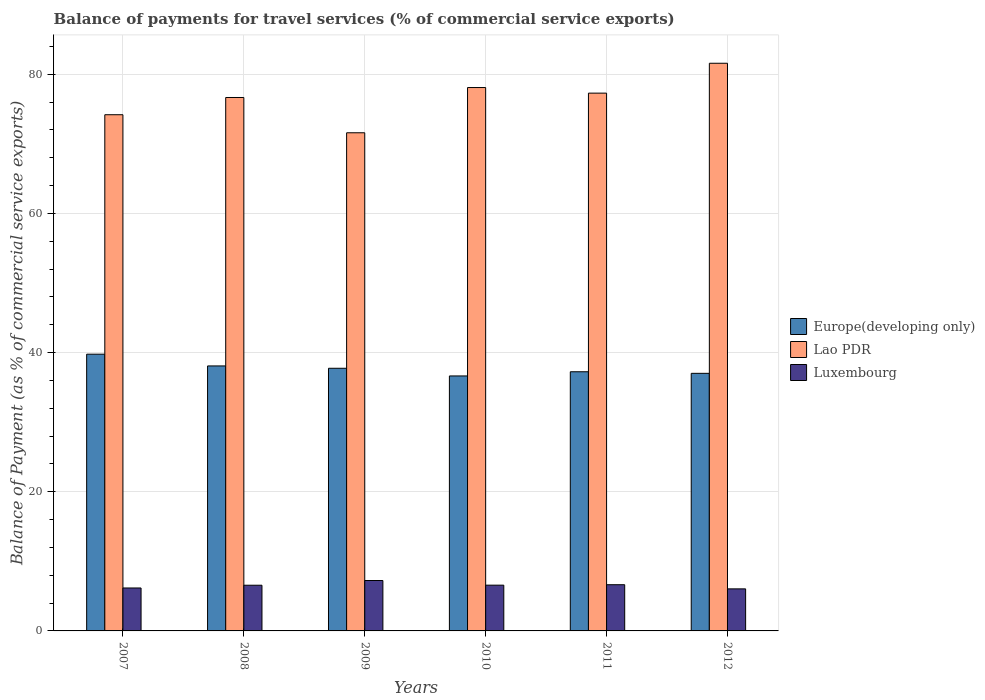How many different coloured bars are there?
Provide a short and direct response. 3. Are the number of bars on each tick of the X-axis equal?
Your response must be concise. Yes. In how many cases, is the number of bars for a given year not equal to the number of legend labels?
Offer a terse response. 0. What is the balance of payments for travel services in Europe(developing only) in 2012?
Offer a very short reply. 37.02. Across all years, what is the maximum balance of payments for travel services in Europe(developing only)?
Provide a succinct answer. 39.77. Across all years, what is the minimum balance of payments for travel services in Europe(developing only)?
Provide a short and direct response. 36.64. In which year was the balance of payments for travel services in Luxembourg minimum?
Give a very brief answer. 2012. What is the total balance of payments for travel services in Europe(developing only) in the graph?
Your answer should be compact. 226.49. What is the difference between the balance of payments for travel services in Lao PDR in 2009 and that in 2011?
Keep it short and to the point. -5.7. What is the difference between the balance of payments for travel services in Europe(developing only) in 2008 and the balance of payments for travel services in Luxembourg in 2010?
Keep it short and to the point. 31.5. What is the average balance of payments for travel services in Europe(developing only) per year?
Provide a succinct answer. 37.75. In the year 2010, what is the difference between the balance of payments for travel services in Europe(developing only) and balance of payments for travel services in Lao PDR?
Ensure brevity in your answer.  -41.44. What is the ratio of the balance of payments for travel services in Luxembourg in 2010 to that in 2012?
Ensure brevity in your answer.  1.09. Is the balance of payments for travel services in Luxembourg in 2008 less than that in 2010?
Provide a succinct answer. Yes. Is the difference between the balance of payments for travel services in Europe(developing only) in 2007 and 2008 greater than the difference between the balance of payments for travel services in Lao PDR in 2007 and 2008?
Give a very brief answer. Yes. What is the difference between the highest and the second highest balance of payments for travel services in Europe(developing only)?
Give a very brief answer. 1.69. What is the difference between the highest and the lowest balance of payments for travel services in Luxembourg?
Your response must be concise. 1.2. In how many years, is the balance of payments for travel services in Europe(developing only) greater than the average balance of payments for travel services in Europe(developing only) taken over all years?
Your answer should be compact. 2. What does the 3rd bar from the left in 2011 represents?
Keep it short and to the point. Luxembourg. What does the 2nd bar from the right in 2010 represents?
Your answer should be compact. Lao PDR. How many bars are there?
Keep it short and to the point. 18. How many years are there in the graph?
Provide a short and direct response. 6. Does the graph contain any zero values?
Offer a very short reply. No. Does the graph contain grids?
Make the answer very short. Yes. Where does the legend appear in the graph?
Your answer should be compact. Center right. How are the legend labels stacked?
Offer a very short reply. Vertical. What is the title of the graph?
Provide a succinct answer. Balance of payments for travel services (% of commercial service exports). What is the label or title of the Y-axis?
Provide a succinct answer. Balance of Payment (as % of commercial service exports). What is the Balance of Payment (as % of commercial service exports) of Europe(developing only) in 2007?
Offer a terse response. 39.77. What is the Balance of Payment (as % of commercial service exports) of Lao PDR in 2007?
Provide a short and direct response. 74.18. What is the Balance of Payment (as % of commercial service exports) in Luxembourg in 2007?
Give a very brief answer. 6.17. What is the Balance of Payment (as % of commercial service exports) in Europe(developing only) in 2008?
Offer a very short reply. 38.08. What is the Balance of Payment (as % of commercial service exports) in Lao PDR in 2008?
Keep it short and to the point. 76.65. What is the Balance of Payment (as % of commercial service exports) of Luxembourg in 2008?
Offer a terse response. 6.57. What is the Balance of Payment (as % of commercial service exports) in Europe(developing only) in 2009?
Give a very brief answer. 37.74. What is the Balance of Payment (as % of commercial service exports) of Lao PDR in 2009?
Provide a short and direct response. 71.58. What is the Balance of Payment (as % of commercial service exports) in Luxembourg in 2009?
Offer a terse response. 7.24. What is the Balance of Payment (as % of commercial service exports) in Europe(developing only) in 2010?
Your answer should be very brief. 36.64. What is the Balance of Payment (as % of commercial service exports) of Lao PDR in 2010?
Offer a terse response. 78.08. What is the Balance of Payment (as % of commercial service exports) of Luxembourg in 2010?
Keep it short and to the point. 6.58. What is the Balance of Payment (as % of commercial service exports) of Europe(developing only) in 2011?
Your answer should be very brief. 37.24. What is the Balance of Payment (as % of commercial service exports) of Lao PDR in 2011?
Offer a terse response. 77.28. What is the Balance of Payment (as % of commercial service exports) in Luxembourg in 2011?
Your answer should be compact. 6.64. What is the Balance of Payment (as % of commercial service exports) of Europe(developing only) in 2012?
Make the answer very short. 37.02. What is the Balance of Payment (as % of commercial service exports) in Lao PDR in 2012?
Provide a succinct answer. 81.57. What is the Balance of Payment (as % of commercial service exports) in Luxembourg in 2012?
Your response must be concise. 6.04. Across all years, what is the maximum Balance of Payment (as % of commercial service exports) in Europe(developing only)?
Offer a very short reply. 39.77. Across all years, what is the maximum Balance of Payment (as % of commercial service exports) in Lao PDR?
Make the answer very short. 81.57. Across all years, what is the maximum Balance of Payment (as % of commercial service exports) in Luxembourg?
Offer a very short reply. 7.24. Across all years, what is the minimum Balance of Payment (as % of commercial service exports) in Europe(developing only)?
Your response must be concise. 36.64. Across all years, what is the minimum Balance of Payment (as % of commercial service exports) in Lao PDR?
Your answer should be very brief. 71.58. Across all years, what is the minimum Balance of Payment (as % of commercial service exports) of Luxembourg?
Make the answer very short. 6.04. What is the total Balance of Payment (as % of commercial service exports) of Europe(developing only) in the graph?
Give a very brief answer. 226.49. What is the total Balance of Payment (as % of commercial service exports) in Lao PDR in the graph?
Offer a very short reply. 459.36. What is the total Balance of Payment (as % of commercial service exports) of Luxembourg in the graph?
Keep it short and to the point. 39.24. What is the difference between the Balance of Payment (as % of commercial service exports) in Europe(developing only) in 2007 and that in 2008?
Provide a succinct answer. 1.69. What is the difference between the Balance of Payment (as % of commercial service exports) of Lao PDR in 2007 and that in 2008?
Your answer should be compact. -2.48. What is the difference between the Balance of Payment (as % of commercial service exports) in Luxembourg in 2007 and that in 2008?
Your answer should be compact. -0.4. What is the difference between the Balance of Payment (as % of commercial service exports) in Europe(developing only) in 2007 and that in 2009?
Make the answer very short. 2.03. What is the difference between the Balance of Payment (as % of commercial service exports) in Lao PDR in 2007 and that in 2009?
Your answer should be very brief. 2.59. What is the difference between the Balance of Payment (as % of commercial service exports) of Luxembourg in 2007 and that in 2009?
Your answer should be very brief. -1.07. What is the difference between the Balance of Payment (as % of commercial service exports) in Europe(developing only) in 2007 and that in 2010?
Make the answer very short. 3.13. What is the difference between the Balance of Payment (as % of commercial service exports) of Lao PDR in 2007 and that in 2010?
Offer a very short reply. -3.91. What is the difference between the Balance of Payment (as % of commercial service exports) in Luxembourg in 2007 and that in 2010?
Your response must be concise. -0.41. What is the difference between the Balance of Payment (as % of commercial service exports) of Europe(developing only) in 2007 and that in 2011?
Offer a very short reply. 2.53. What is the difference between the Balance of Payment (as % of commercial service exports) of Lao PDR in 2007 and that in 2011?
Offer a terse response. -3.1. What is the difference between the Balance of Payment (as % of commercial service exports) of Luxembourg in 2007 and that in 2011?
Give a very brief answer. -0.47. What is the difference between the Balance of Payment (as % of commercial service exports) in Europe(developing only) in 2007 and that in 2012?
Offer a terse response. 2.75. What is the difference between the Balance of Payment (as % of commercial service exports) of Lao PDR in 2007 and that in 2012?
Ensure brevity in your answer.  -7.4. What is the difference between the Balance of Payment (as % of commercial service exports) of Luxembourg in 2007 and that in 2012?
Provide a succinct answer. 0.13. What is the difference between the Balance of Payment (as % of commercial service exports) of Europe(developing only) in 2008 and that in 2009?
Provide a short and direct response. 0.34. What is the difference between the Balance of Payment (as % of commercial service exports) in Lao PDR in 2008 and that in 2009?
Make the answer very short. 5.07. What is the difference between the Balance of Payment (as % of commercial service exports) in Luxembourg in 2008 and that in 2009?
Keep it short and to the point. -0.68. What is the difference between the Balance of Payment (as % of commercial service exports) in Europe(developing only) in 2008 and that in 2010?
Ensure brevity in your answer.  1.44. What is the difference between the Balance of Payment (as % of commercial service exports) in Lao PDR in 2008 and that in 2010?
Provide a succinct answer. -1.43. What is the difference between the Balance of Payment (as % of commercial service exports) of Luxembourg in 2008 and that in 2010?
Your response must be concise. -0.01. What is the difference between the Balance of Payment (as % of commercial service exports) of Europe(developing only) in 2008 and that in 2011?
Make the answer very short. 0.84. What is the difference between the Balance of Payment (as % of commercial service exports) in Lao PDR in 2008 and that in 2011?
Your answer should be compact. -0.63. What is the difference between the Balance of Payment (as % of commercial service exports) of Luxembourg in 2008 and that in 2011?
Provide a succinct answer. -0.07. What is the difference between the Balance of Payment (as % of commercial service exports) of Europe(developing only) in 2008 and that in 2012?
Offer a terse response. 1.06. What is the difference between the Balance of Payment (as % of commercial service exports) of Lao PDR in 2008 and that in 2012?
Give a very brief answer. -4.92. What is the difference between the Balance of Payment (as % of commercial service exports) in Luxembourg in 2008 and that in 2012?
Offer a terse response. 0.52. What is the difference between the Balance of Payment (as % of commercial service exports) of Europe(developing only) in 2009 and that in 2010?
Your answer should be very brief. 1.1. What is the difference between the Balance of Payment (as % of commercial service exports) in Lao PDR in 2009 and that in 2010?
Offer a terse response. -6.5. What is the difference between the Balance of Payment (as % of commercial service exports) of Luxembourg in 2009 and that in 2010?
Provide a short and direct response. 0.67. What is the difference between the Balance of Payment (as % of commercial service exports) in Europe(developing only) in 2009 and that in 2011?
Keep it short and to the point. 0.5. What is the difference between the Balance of Payment (as % of commercial service exports) in Lao PDR in 2009 and that in 2011?
Your answer should be very brief. -5.7. What is the difference between the Balance of Payment (as % of commercial service exports) of Luxembourg in 2009 and that in 2011?
Give a very brief answer. 0.6. What is the difference between the Balance of Payment (as % of commercial service exports) of Europe(developing only) in 2009 and that in 2012?
Offer a very short reply. 0.73. What is the difference between the Balance of Payment (as % of commercial service exports) in Lao PDR in 2009 and that in 2012?
Your answer should be compact. -9.99. What is the difference between the Balance of Payment (as % of commercial service exports) in Luxembourg in 2009 and that in 2012?
Provide a succinct answer. 1.2. What is the difference between the Balance of Payment (as % of commercial service exports) in Europe(developing only) in 2010 and that in 2011?
Keep it short and to the point. -0.6. What is the difference between the Balance of Payment (as % of commercial service exports) in Lao PDR in 2010 and that in 2011?
Provide a succinct answer. 0.8. What is the difference between the Balance of Payment (as % of commercial service exports) of Luxembourg in 2010 and that in 2011?
Offer a terse response. -0.07. What is the difference between the Balance of Payment (as % of commercial service exports) in Europe(developing only) in 2010 and that in 2012?
Keep it short and to the point. -0.37. What is the difference between the Balance of Payment (as % of commercial service exports) of Lao PDR in 2010 and that in 2012?
Keep it short and to the point. -3.49. What is the difference between the Balance of Payment (as % of commercial service exports) in Luxembourg in 2010 and that in 2012?
Provide a succinct answer. 0.53. What is the difference between the Balance of Payment (as % of commercial service exports) of Europe(developing only) in 2011 and that in 2012?
Give a very brief answer. 0.23. What is the difference between the Balance of Payment (as % of commercial service exports) of Lao PDR in 2011 and that in 2012?
Offer a terse response. -4.29. What is the difference between the Balance of Payment (as % of commercial service exports) in Luxembourg in 2011 and that in 2012?
Ensure brevity in your answer.  0.6. What is the difference between the Balance of Payment (as % of commercial service exports) of Europe(developing only) in 2007 and the Balance of Payment (as % of commercial service exports) of Lao PDR in 2008?
Provide a succinct answer. -36.89. What is the difference between the Balance of Payment (as % of commercial service exports) in Europe(developing only) in 2007 and the Balance of Payment (as % of commercial service exports) in Luxembourg in 2008?
Your answer should be very brief. 33.2. What is the difference between the Balance of Payment (as % of commercial service exports) of Lao PDR in 2007 and the Balance of Payment (as % of commercial service exports) of Luxembourg in 2008?
Make the answer very short. 67.61. What is the difference between the Balance of Payment (as % of commercial service exports) in Europe(developing only) in 2007 and the Balance of Payment (as % of commercial service exports) in Lao PDR in 2009?
Provide a succinct answer. -31.82. What is the difference between the Balance of Payment (as % of commercial service exports) of Europe(developing only) in 2007 and the Balance of Payment (as % of commercial service exports) of Luxembourg in 2009?
Keep it short and to the point. 32.52. What is the difference between the Balance of Payment (as % of commercial service exports) in Lao PDR in 2007 and the Balance of Payment (as % of commercial service exports) in Luxembourg in 2009?
Give a very brief answer. 66.93. What is the difference between the Balance of Payment (as % of commercial service exports) in Europe(developing only) in 2007 and the Balance of Payment (as % of commercial service exports) in Lao PDR in 2010?
Provide a succinct answer. -38.31. What is the difference between the Balance of Payment (as % of commercial service exports) in Europe(developing only) in 2007 and the Balance of Payment (as % of commercial service exports) in Luxembourg in 2010?
Keep it short and to the point. 33.19. What is the difference between the Balance of Payment (as % of commercial service exports) of Lao PDR in 2007 and the Balance of Payment (as % of commercial service exports) of Luxembourg in 2010?
Your answer should be compact. 67.6. What is the difference between the Balance of Payment (as % of commercial service exports) of Europe(developing only) in 2007 and the Balance of Payment (as % of commercial service exports) of Lao PDR in 2011?
Provide a short and direct response. -37.51. What is the difference between the Balance of Payment (as % of commercial service exports) of Europe(developing only) in 2007 and the Balance of Payment (as % of commercial service exports) of Luxembourg in 2011?
Your answer should be very brief. 33.13. What is the difference between the Balance of Payment (as % of commercial service exports) of Lao PDR in 2007 and the Balance of Payment (as % of commercial service exports) of Luxembourg in 2011?
Keep it short and to the point. 67.54. What is the difference between the Balance of Payment (as % of commercial service exports) in Europe(developing only) in 2007 and the Balance of Payment (as % of commercial service exports) in Lao PDR in 2012?
Ensure brevity in your answer.  -41.81. What is the difference between the Balance of Payment (as % of commercial service exports) in Europe(developing only) in 2007 and the Balance of Payment (as % of commercial service exports) in Luxembourg in 2012?
Your response must be concise. 33.73. What is the difference between the Balance of Payment (as % of commercial service exports) of Lao PDR in 2007 and the Balance of Payment (as % of commercial service exports) of Luxembourg in 2012?
Keep it short and to the point. 68.13. What is the difference between the Balance of Payment (as % of commercial service exports) of Europe(developing only) in 2008 and the Balance of Payment (as % of commercial service exports) of Lao PDR in 2009?
Keep it short and to the point. -33.51. What is the difference between the Balance of Payment (as % of commercial service exports) of Europe(developing only) in 2008 and the Balance of Payment (as % of commercial service exports) of Luxembourg in 2009?
Your response must be concise. 30.84. What is the difference between the Balance of Payment (as % of commercial service exports) in Lao PDR in 2008 and the Balance of Payment (as % of commercial service exports) in Luxembourg in 2009?
Offer a terse response. 69.41. What is the difference between the Balance of Payment (as % of commercial service exports) of Europe(developing only) in 2008 and the Balance of Payment (as % of commercial service exports) of Lao PDR in 2010?
Offer a very short reply. -40. What is the difference between the Balance of Payment (as % of commercial service exports) of Europe(developing only) in 2008 and the Balance of Payment (as % of commercial service exports) of Luxembourg in 2010?
Make the answer very short. 31.5. What is the difference between the Balance of Payment (as % of commercial service exports) of Lao PDR in 2008 and the Balance of Payment (as % of commercial service exports) of Luxembourg in 2010?
Your response must be concise. 70.08. What is the difference between the Balance of Payment (as % of commercial service exports) in Europe(developing only) in 2008 and the Balance of Payment (as % of commercial service exports) in Lao PDR in 2011?
Provide a succinct answer. -39.2. What is the difference between the Balance of Payment (as % of commercial service exports) in Europe(developing only) in 2008 and the Balance of Payment (as % of commercial service exports) in Luxembourg in 2011?
Make the answer very short. 31.44. What is the difference between the Balance of Payment (as % of commercial service exports) of Lao PDR in 2008 and the Balance of Payment (as % of commercial service exports) of Luxembourg in 2011?
Provide a succinct answer. 70.01. What is the difference between the Balance of Payment (as % of commercial service exports) of Europe(developing only) in 2008 and the Balance of Payment (as % of commercial service exports) of Lao PDR in 2012?
Make the answer very short. -43.49. What is the difference between the Balance of Payment (as % of commercial service exports) in Europe(developing only) in 2008 and the Balance of Payment (as % of commercial service exports) in Luxembourg in 2012?
Ensure brevity in your answer.  32.04. What is the difference between the Balance of Payment (as % of commercial service exports) in Lao PDR in 2008 and the Balance of Payment (as % of commercial service exports) in Luxembourg in 2012?
Offer a terse response. 70.61. What is the difference between the Balance of Payment (as % of commercial service exports) of Europe(developing only) in 2009 and the Balance of Payment (as % of commercial service exports) of Lao PDR in 2010?
Provide a short and direct response. -40.34. What is the difference between the Balance of Payment (as % of commercial service exports) in Europe(developing only) in 2009 and the Balance of Payment (as % of commercial service exports) in Luxembourg in 2010?
Give a very brief answer. 31.17. What is the difference between the Balance of Payment (as % of commercial service exports) in Lao PDR in 2009 and the Balance of Payment (as % of commercial service exports) in Luxembourg in 2010?
Your response must be concise. 65.01. What is the difference between the Balance of Payment (as % of commercial service exports) in Europe(developing only) in 2009 and the Balance of Payment (as % of commercial service exports) in Lao PDR in 2011?
Make the answer very short. -39.54. What is the difference between the Balance of Payment (as % of commercial service exports) of Europe(developing only) in 2009 and the Balance of Payment (as % of commercial service exports) of Luxembourg in 2011?
Your answer should be compact. 31.1. What is the difference between the Balance of Payment (as % of commercial service exports) of Lao PDR in 2009 and the Balance of Payment (as % of commercial service exports) of Luxembourg in 2011?
Your response must be concise. 64.94. What is the difference between the Balance of Payment (as % of commercial service exports) in Europe(developing only) in 2009 and the Balance of Payment (as % of commercial service exports) in Lao PDR in 2012?
Offer a very short reply. -43.83. What is the difference between the Balance of Payment (as % of commercial service exports) of Europe(developing only) in 2009 and the Balance of Payment (as % of commercial service exports) of Luxembourg in 2012?
Your answer should be very brief. 31.7. What is the difference between the Balance of Payment (as % of commercial service exports) of Lao PDR in 2009 and the Balance of Payment (as % of commercial service exports) of Luxembourg in 2012?
Your response must be concise. 65.54. What is the difference between the Balance of Payment (as % of commercial service exports) of Europe(developing only) in 2010 and the Balance of Payment (as % of commercial service exports) of Lao PDR in 2011?
Your answer should be very brief. -40.64. What is the difference between the Balance of Payment (as % of commercial service exports) of Europe(developing only) in 2010 and the Balance of Payment (as % of commercial service exports) of Luxembourg in 2011?
Provide a short and direct response. 30. What is the difference between the Balance of Payment (as % of commercial service exports) of Lao PDR in 2010 and the Balance of Payment (as % of commercial service exports) of Luxembourg in 2011?
Give a very brief answer. 71.44. What is the difference between the Balance of Payment (as % of commercial service exports) of Europe(developing only) in 2010 and the Balance of Payment (as % of commercial service exports) of Lao PDR in 2012?
Provide a short and direct response. -44.93. What is the difference between the Balance of Payment (as % of commercial service exports) in Europe(developing only) in 2010 and the Balance of Payment (as % of commercial service exports) in Luxembourg in 2012?
Ensure brevity in your answer.  30.6. What is the difference between the Balance of Payment (as % of commercial service exports) in Lao PDR in 2010 and the Balance of Payment (as % of commercial service exports) in Luxembourg in 2012?
Make the answer very short. 72.04. What is the difference between the Balance of Payment (as % of commercial service exports) in Europe(developing only) in 2011 and the Balance of Payment (as % of commercial service exports) in Lao PDR in 2012?
Provide a short and direct response. -44.33. What is the difference between the Balance of Payment (as % of commercial service exports) of Europe(developing only) in 2011 and the Balance of Payment (as % of commercial service exports) of Luxembourg in 2012?
Offer a very short reply. 31.2. What is the difference between the Balance of Payment (as % of commercial service exports) of Lao PDR in 2011 and the Balance of Payment (as % of commercial service exports) of Luxembourg in 2012?
Provide a short and direct response. 71.24. What is the average Balance of Payment (as % of commercial service exports) of Europe(developing only) per year?
Keep it short and to the point. 37.75. What is the average Balance of Payment (as % of commercial service exports) of Lao PDR per year?
Ensure brevity in your answer.  76.56. What is the average Balance of Payment (as % of commercial service exports) in Luxembourg per year?
Your answer should be compact. 6.54. In the year 2007, what is the difference between the Balance of Payment (as % of commercial service exports) of Europe(developing only) and Balance of Payment (as % of commercial service exports) of Lao PDR?
Ensure brevity in your answer.  -34.41. In the year 2007, what is the difference between the Balance of Payment (as % of commercial service exports) in Europe(developing only) and Balance of Payment (as % of commercial service exports) in Luxembourg?
Your response must be concise. 33.6. In the year 2007, what is the difference between the Balance of Payment (as % of commercial service exports) in Lao PDR and Balance of Payment (as % of commercial service exports) in Luxembourg?
Provide a succinct answer. 68.01. In the year 2008, what is the difference between the Balance of Payment (as % of commercial service exports) of Europe(developing only) and Balance of Payment (as % of commercial service exports) of Lao PDR?
Your answer should be compact. -38.57. In the year 2008, what is the difference between the Balance of Payment (as % of commercial service exports) of Europe(developing only) and Balance of Payment (as % of commercial service exports) of Luxembourg?
Keep it short and to the point. 31.51. In the year 2008, what is the difference between the Balance of Payment (as % of commercial service exports) of Lao PDR and Balance of Payment (as % of commercial service exports) of Luxembourg?
Your response must be concise. 70.09. In the year 2009, what is the difference between the Balance of Payment (as % of commercial service exports) in Europe(developing only) and Balance of Payment (as % of commercial service exports) in Lao PDR?
Offer a very short reply. -33.84. In the year 2009, what is the difference between the Balance of Payment (as % of commercial service exports) of Europe(developing only) and Balance of Payment (as % of commercial service exports) of Luxembourg?
Ensure brevity in your answer.  30.5. In the year 2009, what is the difference between the Balance of Payment (as % of commercial service exports) of Lao PDR and Balance of Payment (as % of commercial service exports) of Luxembourg?
Provide a succinct answer. 64.34. In the year 2010, what is the difference between the Balance of Payment (as % of commercial service exports) in Europe(developing only) and Balance of Payment (as % of commercial service exports) in Lao PDR?
Make the answer very short. -41.44. In the year 2010, what is the difference between the Balance of Payment (as % of commercial service exports) in Europe(developing only) and Balance of Payment (as % of commercial service exports) in Luxembourg?
Your response must be concise. 30.07. In the year 2010, what is the difference between the Balance of Payment (as % of commercial service exports) in Lao PDR and Balance of Payment (as % of commercial service exports) in Luxembourg?
Provide a succinct answer. 71.51. In the year 2011, what is the difference between the Balance of Payment (as % of commercial service exports) of Europe(developing only) and Balance of Payment (as % of commercial service exports) of Lao PDR?
Provide a short and direct response. -40.04. In the year 2011, what is the difference between the Balance of Payment (as % of commercial service exports) of Europe(developing only) and Balance of Payment (as % of commercial service exports) of Luxembourg?
Make the answer very short. 30.6. In the year 2011, what is the difference between the Balance of Payment (as % of commercial service exports) of Lao PDR and Balance of Payment (as % of commercial service exports) of Luxembourg?
Provide a succinct answer. 70.64. In the year 2012, what is the difference between the Balance of Payment (as % of commercial service exports) of Europe(developing only) and Balance of Payment (as % of commercial service exports) of Lao PDR?
Make the answer very short. -44.56. In the year 2012, what is the difference between the Balance of Payment (as % of commercial service exports) in Europe(developing only) and Balance of Payment (as % of commercial service exports) in Luxembourg?
Ensure brevity in your answer.  30.97. In the year 2012, what is the difference between the Balance of Payment (as % of commercial service exports) of Lao PDR and Balance of Payment (as % of commercial service exports) of Luxembourg?
Your response must be concise. 75.53. What is the ratio of the Balance of Payment (as % of commercial service exports) in Europe(developing only) in 2007 to that in 2008?
Make the answer very short. 1.04. What is the ratio of the Balance of Payment (as % of commercial service exports) in Lao PDR in 2007 to that in 2008?
Keep it short and to the point. 0.97. What is the ratio of the Balance of Payment (as % of commercial service exports) of Luxembourg in 2007 to that in 2008?
Your answer should be very brief. 0.94. What is the ratio of the Balance of Payment (as % of commercial service exports) in Europe(developing only) in 2007 to that in 2009?
Your answer should be compact. 1.05. What is the ratio of the Balance of Payment (as % of commercial service exports) of Lao PDR in 2007 to that in 2009?
Ensure brevity in your answer.  1.04. What is the ratio of the Balance of Payment (as % of commercial service exports) in Luxembourg in 2007 to that in 2009?
Your response must be concise. 0.85. What is the ratio of the Balance of Payment (as % of commercial service exports) of Europe(developing only) in 2007 to that in 2010?
Give a very brief answer. 1.09. What is the ratio of the Balance of Payment (as % of commercial service exports) in Lao PDR in 2007 to that in 2010?
Provide a succinct answer. 0.95. What is the ratio of the Balance of Payment (as % of commercial service exports) of Luxembourg in 2007 to that in 2010?
Ensure brevity in your answer.  0.94. What is the ratio of the Balance of Payment (as % of commercial service exports) in Europe(developing only) in 2007 to that in 2011?
Your answer should be very brief. 1.07. What is the ratio of the Balance of Payment (as % of commercial service exports) in Lao PDR in 2007 to that in 2011?
Your response must be concise. 0.96. What is the ratio of the Balance of Payment (as % of commercial service exports) of Luxembourg in 2007 to that in 2011?
Make the answer very short. 0.93. What is the ratio of the Balance of Payment (as % of commercial service exports) of Europe(developing only) in 2007 to that in 2012?
Make the answer very short. 1.07. What is the ratio of the Balance of Payment (as % of commercial service exports) in Lao PDR in 2007 to that in 2012?
Provide a succinct answer. 0.91. What is the ratio of the Balance of Payment (as % of commercial service exports) of Luxembourg in 2007 to that in 2012?
Ensure brevity in your answer.  1.02. What is the ratio of the Balance of Payment (as % of commercial service exports) in Europe(developing only) in 2008 to that in 2009?
Keep it short and to the point. 1.01. What is the ratio of the Balance of Payment (as % of commercial service exports) in Lao PDR in 2008 to that in 2009?
Provide a succinct answer. 1.07. What is the ratio of the Balance of Payment (as % of commercial service exports) of Luxembourg in 2008 to that in 2009?
Give a very brief answer. 0.91. What is the ratio of the Balance of Payment (as % of commercial service exports) of Europe(developing only) in 2008 to that in 2010?
Make the answer very short. 1.04. What is the ratio of the Balance of Payment (as % of commercial service exports) of Lao PDR in 2008 to that in 2010?
Your answer should be very brief. 0.98. What is the ratio of the Balance of Payment (as % of commercial service exports) of Europe(developing only) in 2008 to that in 2011?
Offer a very short reply. 1.02. What is the ratio of the Balance of Payment (as % of commercial service exports) of Lao PDR in 2008 to that in 2011?
Give a very brief answer. 0.99. What is the ratio of the Balance of Payment (as % of commercial service exports) in Luxembourg in 2008 to that in 2011?
Provide a succinct answer. 0.99. What is the ratio of the Balance of Payment (as % of commercial service exports) of Europe(developing only) in 2008 to that in 2012?
Your answer should be compact. 1.03. What is the ratio of the Balance of Payment (as % of commercial service exports) of Lao PDR in 2008 to that in 2012?
Give a very brief answer. 0.94. What is the ratio of the Balance of Payment (as % of commercial service exports) of Luxembourg in 2008 to that in 2012?
Give a very brief answer. 1.09. What is the ratio of the Balance of Payment (as % of commercial service exports) of Europe(developing only) in 2009 to that in 2010?
Provide a succinct answer. 1.03. What is the ratio of the Balance of Payment (as % of commercial service exports) in Lao PDR in 2009 to that in 2010?
Offer a very short reply. 0.92. What is the ratio of the Balance of Payment (as % of commercial service exports) in Luxembourg in 2009 to that in 2010?
Ensure brevity in your answer.  1.1. What is the ratio of the Balance of Payment (as % of commercial service exports) in Europe(developing only) in 2009 to that in 2011?
Your answer should be very brief. 1.01. What is the ratio of the Balance of Payment (as % of commercial service exports) in Lao PDR in 2009 to that in 2011?
Offer a very short reply. 0.93. What is the ratio of the Balance of Payment (as % of commercial service exports) in Luxembourg in 2009 to that in 2011?
Offer a terse response. 1.09. What is the ratio of the Balance of Payment (as % of commercial service exports) of Europe(developing only) in 2009 to that in 2012?
Keep it short and to the point. 1.02. What is the ratio of the Balance of Payment (as % of commercial service exports) of Lao PDR in 2009 to that in 2012?
Give a very brief answer. 0.88. What is the ratio of the Balance of Payment (as % of commercial service exports) of Luxembourg in 2009 to that in 2012?
Ensure brevity in your answer.  1.2. What is the ratio of the Balance of Payment (as % of commercial service exports) of Europe(developing only) in 2010 to that in 2011?
Your response must be concise. 0.98. What is the ratio of the Balance of Payment (as % of commercial service exports) in Lao PDR in 2010 to that in 2011?
Provide a succinct answer. 1.01. What is the ratio of the Balance of Payment (as % of commercial service exports) of Luxembourg in 2010 to that in 2011?
Your answer should be compact. 0.99. What is the ratio of the Balance of Payment (as % of commercial service exports) in Europe(developing only) in 2010 to that in 2012?
Ensure brevity in your answer.  0.99. What is the ratio of the Balance of Payment (as % of commercial service exports) in Lao PDR in 2010 to that in 2012?
Keep it short and to the point. 0.96. What is the ratio of the Balance of Payment (as % of commercial service exports) in Luxembourg in 2010 to that in 2012?
Keep it short and to the point. 1.09. What is the ratio of the Balance of Payment (as % of commercial service exports) of Luxembourg in 2011 to that in 2012?
Make the answer very short. 1.1. What is the difference between the highest and the second highest Balance of Payment (as % of commercial service exports) of Europe(developing only)?
Your response must be concise. 1.69. What is the difference between the highest and the second highest Balance of Payment (as % of commercial service exports) of Lao PDR?
Keep it short and to the point. 3.49. What is the difference between the highest and the second highest Balance of Payment (as % of commercial service exports) in Luxembourg?
Your response must be concise. 0.6. What is the difference between the highest and the lowest Balance of Payment (as % of commercial service exports) in Europe(developing only)?
Your answer should be compact. 3.13. What is the difference between the highest and the lowest Balance of Payment (as % of commercial service exports) in Lao PDR?
Your answer should be compact. 9.99. What is the difference between the highest and the lowest Balance of Payment (as % of commercial service exports) of Luxembourg?
Your answer should be compact. 1.2. 